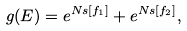<formula> <loc_0><loc_0><loc_500><loc_500>g ( E ) = e ^ { N s [ f _ { 1 } ] } + e ^ { N s [ f _ { 2 } ] } ,</formula> 